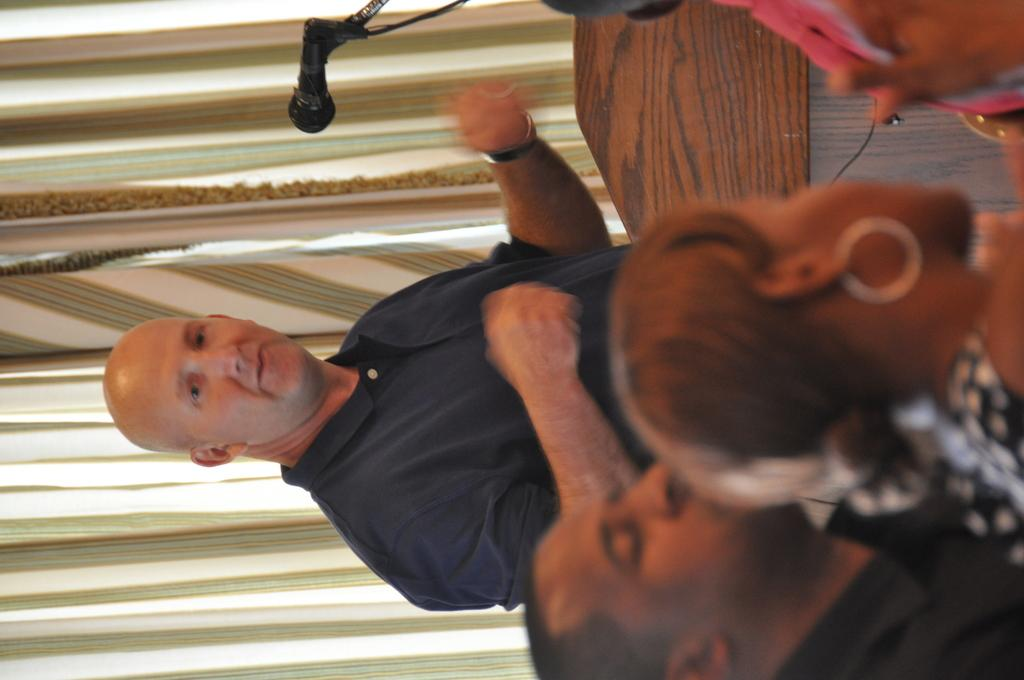How many people are in the image? There are persons in the image, but the exact number is not specified. What object is used for amplifying sound in the image? There is a mic in the image, which is used for amplifying sound. What type of covering is present in the image? There is a curtain in the image. Can you describe any other objects in the image? There are unspecified objects in the image, but their nature is not mentioned. What type of apple is being served as a meal in the image? There is no apple or meal present in the image. Can you tell me how many owls are sitting on the persons' shoulders in the image? There are no owls present in the image. 